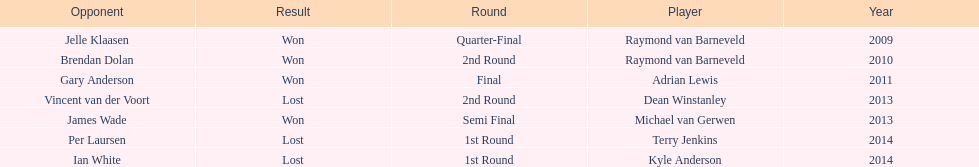Who was the last to win against his opponent? Michael van Gerwen. 